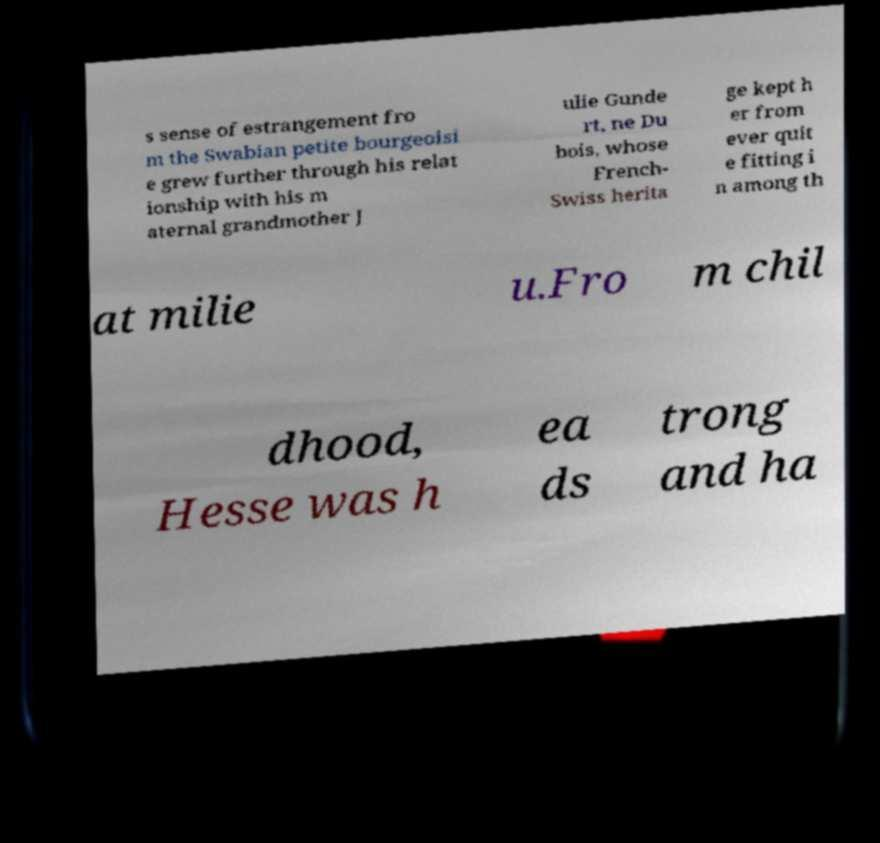For documentation purposes, I need the text within this image transcribed. Could you provide that? s sense of estrangement fro m the Swabian petite bourgeoisi e grew further through his relat ionship with his m aternal grandmother J ulie Gunde rt, ne Du bois, whose French- Swiss herita ge kept h er from ever quit e fitting i n among th at milie u.Fro m chil dhood, Hesse was h ea ds trong and ha 